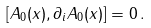Convert formula to latex. <formula><loc_0><loc_0><loc_500><loc_500>[ A _ { 0 } ( x ) , \partial _ { i } A _ { 0 } ( x ) ] = 0 \, .</formula> 